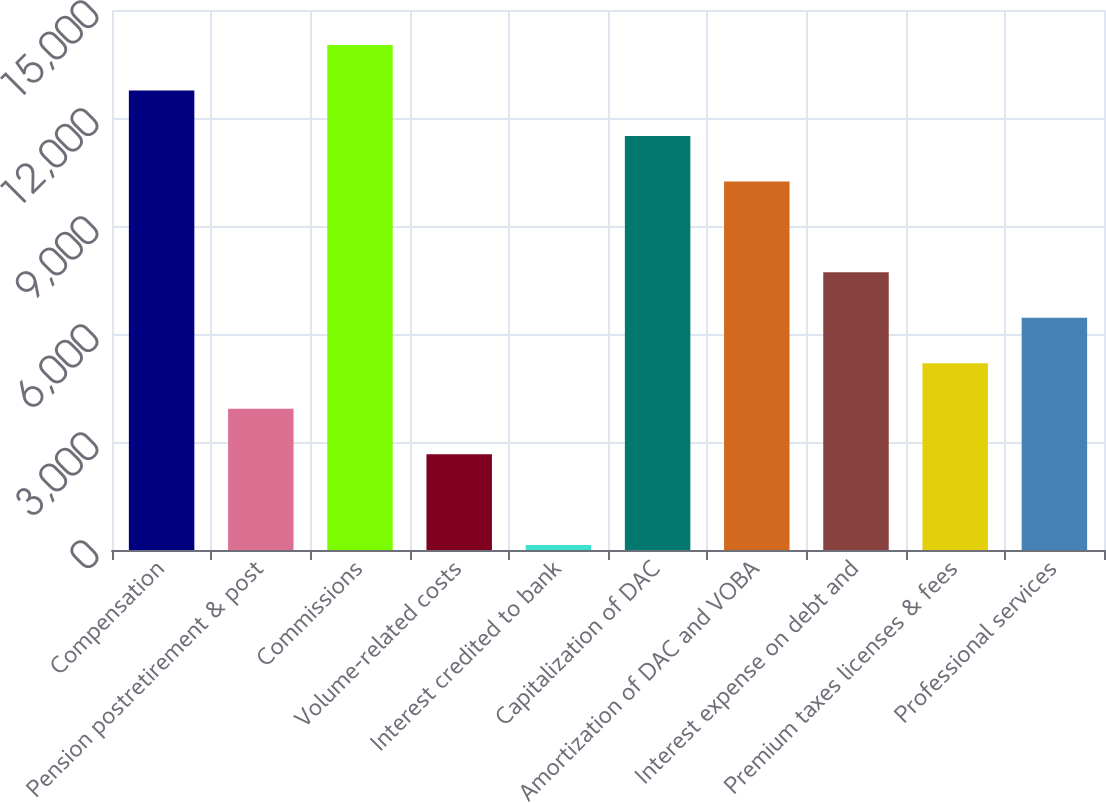Convert chart. <chart><loc_0><loc_0><loc_500><loc_500><bar_chart><fcel>Compensation<fcel>Pension postretirement & post<fcel>Commissions<fcel>Volume-related costs<fcel>Interest credited to bank<fcel>Capitalization of DAC<fcel>Amortization of DAC and VOBA<fcel>Interest expense on debt and<fcel>Premium taxes licenses & fees<fcel>Professional services<nl><fcel>12764<fcel>3925.1<fcel>14026.7<fcel>2662.4<fcel>137<fcel>11501.3<fcel>10238.6<fcel>7713.2<fcel>5187.8<fcel>6450.5<nl></chart> 